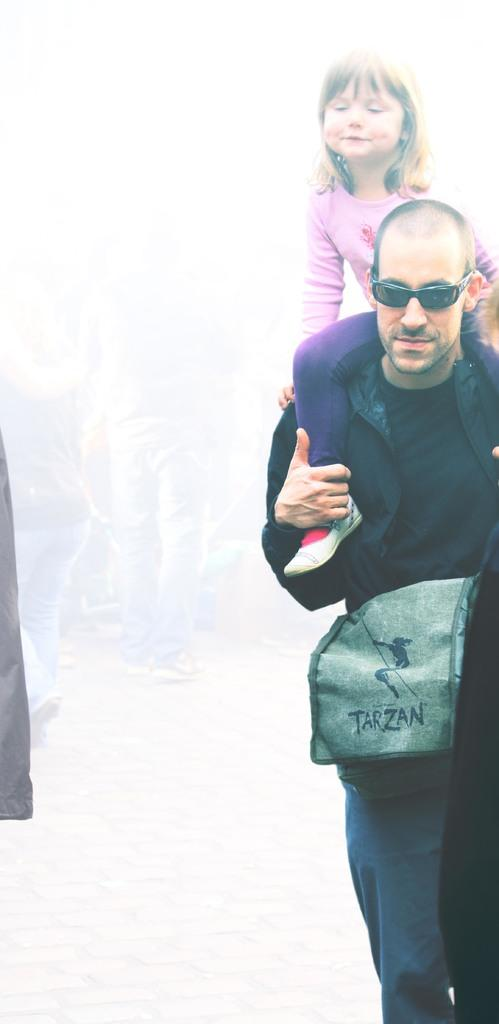What is the person in the image doing? The person is walking on the road in the image. What protective gear is the person wearing? The person is wearing goggles. What is the person carrying while walking? The person is carrying a bag. Is there anyone else with the person in the image? Yes, there is a child sitting on the person. What type of dress is the turkey wearing in the image? There is no turkey present in the image, and therefore no dress to describe. 